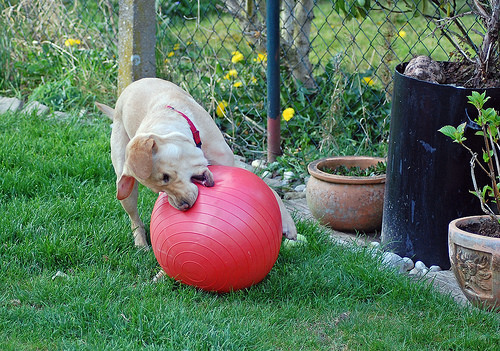<image>
Is there a dog on the ball? Yes. Looking at the image, I can see the dog is positioned on top of the ball, with the ball providing support. 